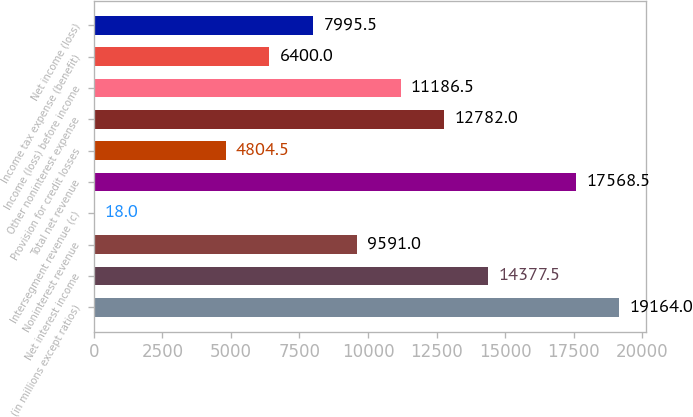Convert chart to OTSL. <chart><loc_0><loc_0><loc_500><loc_500><bar_chart><fcel>(in millions except ratios)<fcel>Net interest income<fcel>Noninterest revenue<fcel>Intersegment revenue (c)<fcel>Total net revenue<fcel>Provision for credit losses<fcel>Other noninterest expense<fcel>Income (loss) before income<fcel>Income tax expense (benefit)<fcel>Net income (loss)<nl><fcel>19164<fcel>14377.5<fcel>9591<fcel>18<fcel>17568.5<fcel>4804.5<fcel>12782<fcel>11186.5<fcel>6400<fcel>7995.5<nl></chart> 